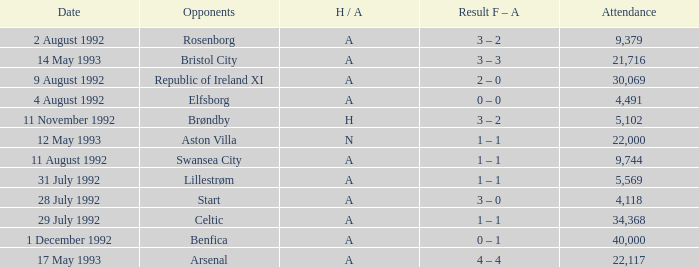Which Result F-A has Opponents of rosenborg? 3 – 2. 